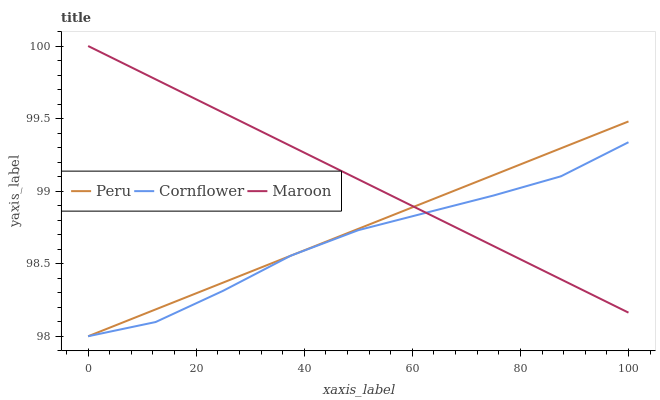Does Cornflower have the minimum area under the curve?
Answer yes or no. Yes. Does Maroon have the maximum area under the curve?
Answer yes or no. Yes. Does Peru have the minimum area under the curve?
Answer yes or no. No. Does Peru have the maximum area under the curve?
Answer yes or no. No. Is Maroon the smoothest?
Answer yes or no. Yes. Is Cornflower the roughest?
Answer yes or no. Yes. Is Peru the smoothest?
Answer yes or no. No. Is Peru the roughest?
Answer yes or no. No. Does Cornflower have the lowest value?
Answer yes or no. Yes. Does Maroon have the lowest value?
Answer yes or no. No. Does Maroon have the highest value?
Answer yes or no. Yes. Does Peru have the highest value?
Answer yes or no. No. Does Maroon intersect Peru?
Answer yes or no. Yes. Is Maroon less than Peru?
Answer yes or no. No. Is Maroon greater than Peru?
Answer yes or no. No. 